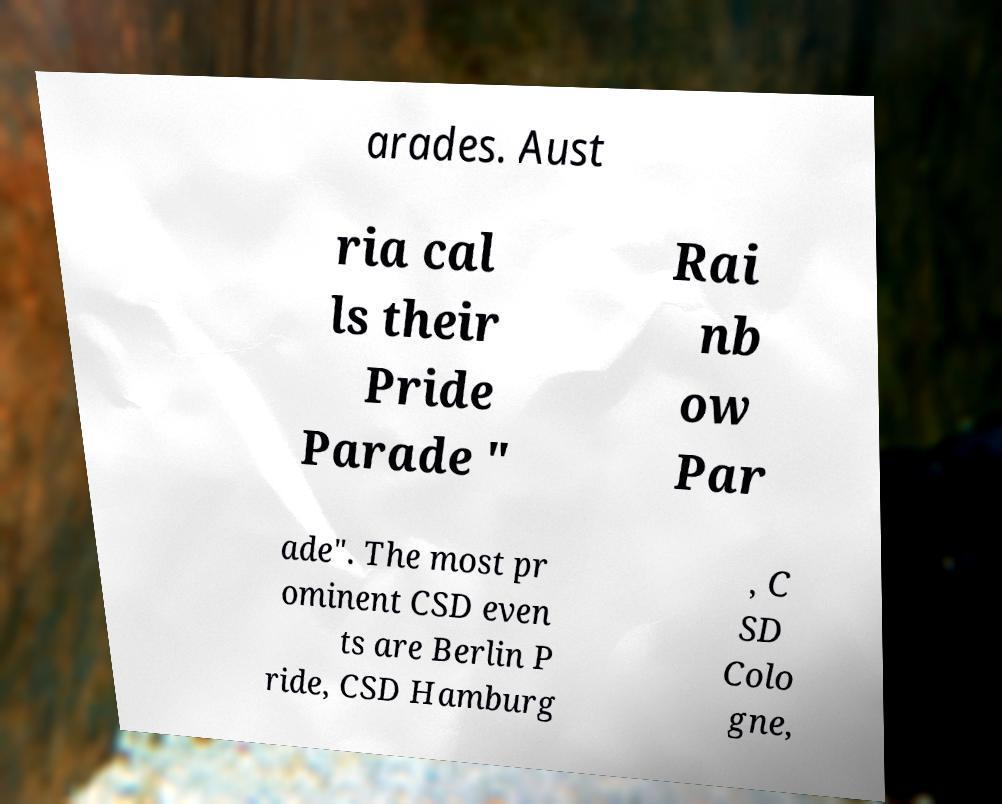Could you extract and type out the text from this image? arades. Aust ria cal ls their Pride Parade " Rai nb ow Par ade". The most pr ominent CSD even ts are Berlin P ride, CSD Hamburg , C SD Colo gne, 